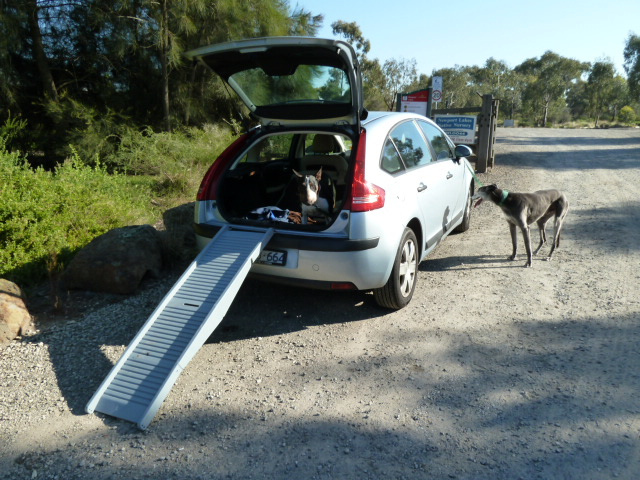Imagine a very short film where the dog inside the car has a mission to help another animal using the ramp. Briefly describe the plot. In a brief heartwarming film, the dog inside the car, Max, notices a stranded baby rabbit near the rocky roadside. Sensing the rabbit is too weak to climb into the car by itself, Max nudges the ramp down gently before coaxing the rabbit up. Once inside, Max curls protectively around the rabbit, ensuring it is warm and safe. The car then drives to the nearest animal rescue center, where the rabbit receives the care it needs. The short film ends with Max watching happily as the rabbit recovers, showcasing a beautiful bond of interspecies friendship and care. 